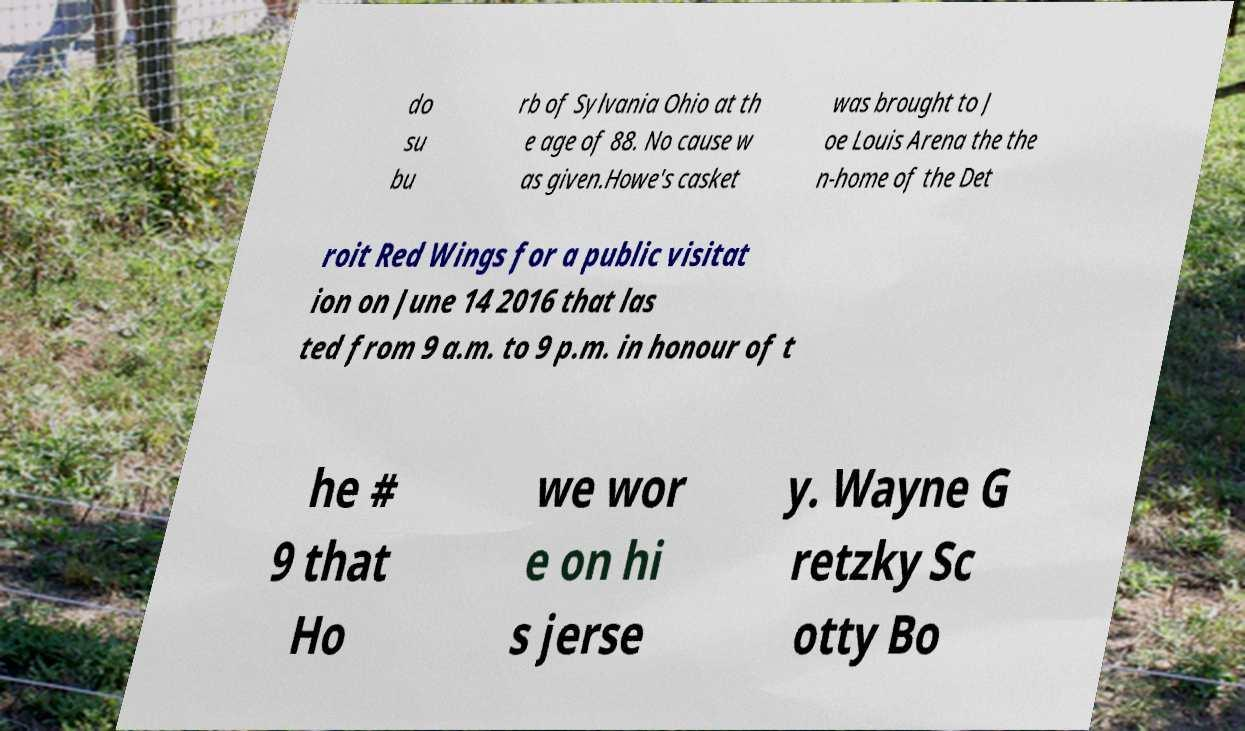Can you read and provide the text displayed in the image?This photo seems to have some interesting text. Can you extract and type it out for me? do su bu rb of Sylvania Ohio at th e age of 88. No cause w as given.Howe's casket was brought to J oe Louis Arena the the n-home of the Det roit Red Wings for a public visitat ion on June 14 2016 that las ted from 9 a.m. to 9 p.m. in honour of t he # 9 that Ho we wor e on hi s jerse y. Wayne G retzky Sc otty Bo 